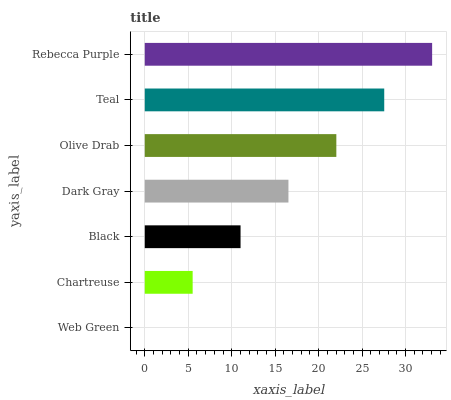Is Web Green the minimum?
Answer yes or no. Yes. Is Rebecca Purple the maximum?
Answer yes or no. Yes. Is Chartreuse the minimum?
Answer yes or no. No. Is Chartreuse the maximum?
Answer yes or no. No. Is Chartreuse greater than Web Green?
Answer yes or no. Yes. Is Web Green less than Chartreuse?
Answer yes or no. Yes. Is Web Green greater than Chartreuse?
Answer yes or no. No. Is Chartreuse less than Web Green?
Answer yes or no. No. Is Dark Gray the high median?
Answer yes or no. Yes. Is Dark Gray the low median?
Answer yes or no. Yes. Is Web Green the high median?
Answer yes or no. No. Is Teal the low median?
Answer yes or no. No. 